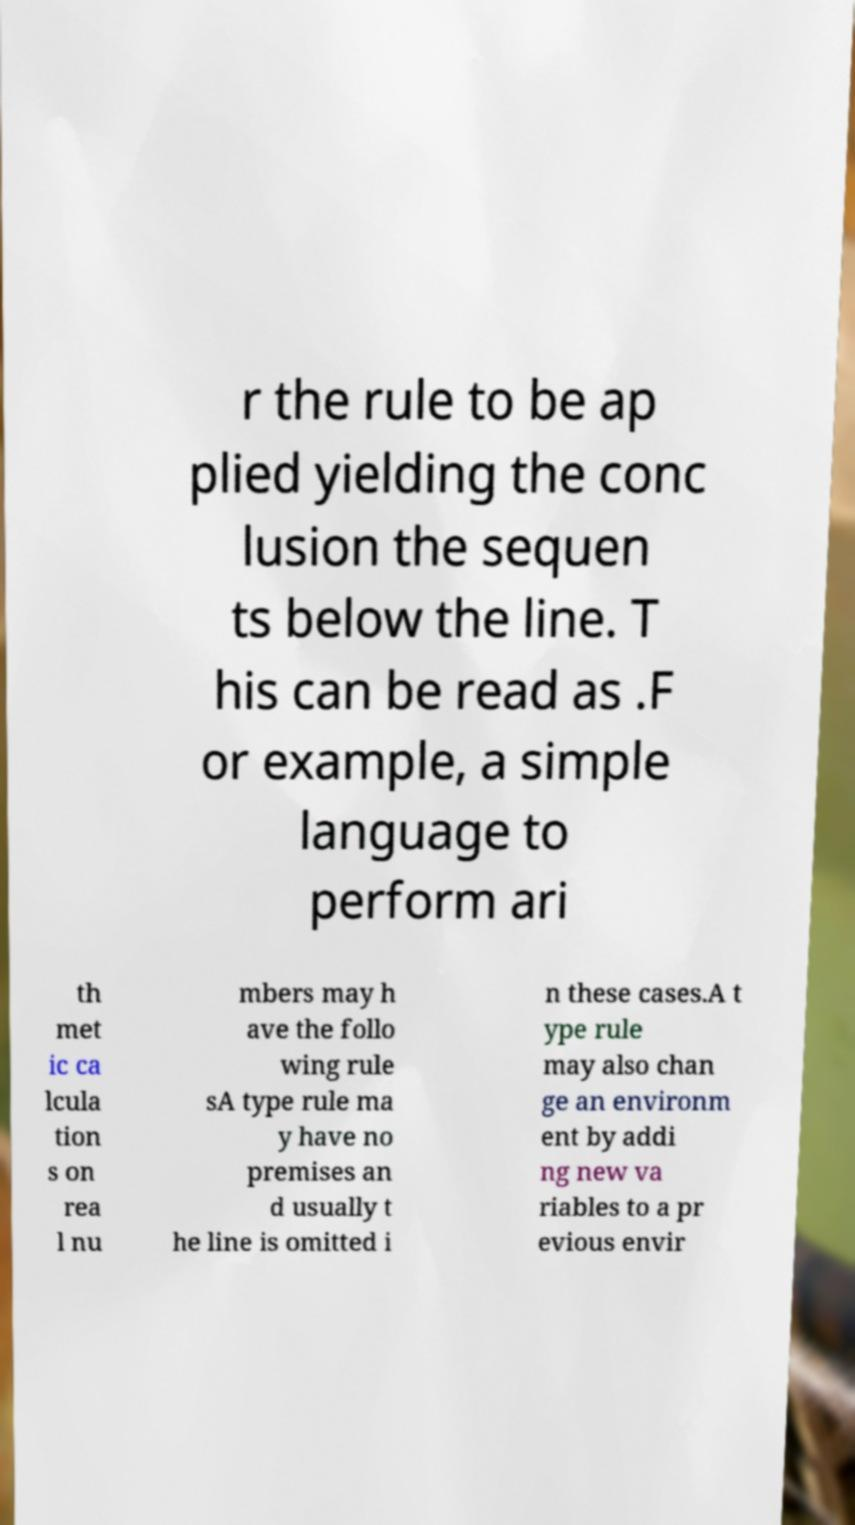Could you extract and type out the text from this image? r the rule to be ap plied yielding the conc lusion the sequen ts below the line. T his can be read as .F or example, a simple language to perform ari th met ic ca lcula tion s on rea l nu mbers may h ave the follo wing rule sA type rule ma y have no premises an d usually t he line is omitted i n these cases.A t ype rule may also chan ge an environm ent by addi ng new va riables to a pr evious envir 